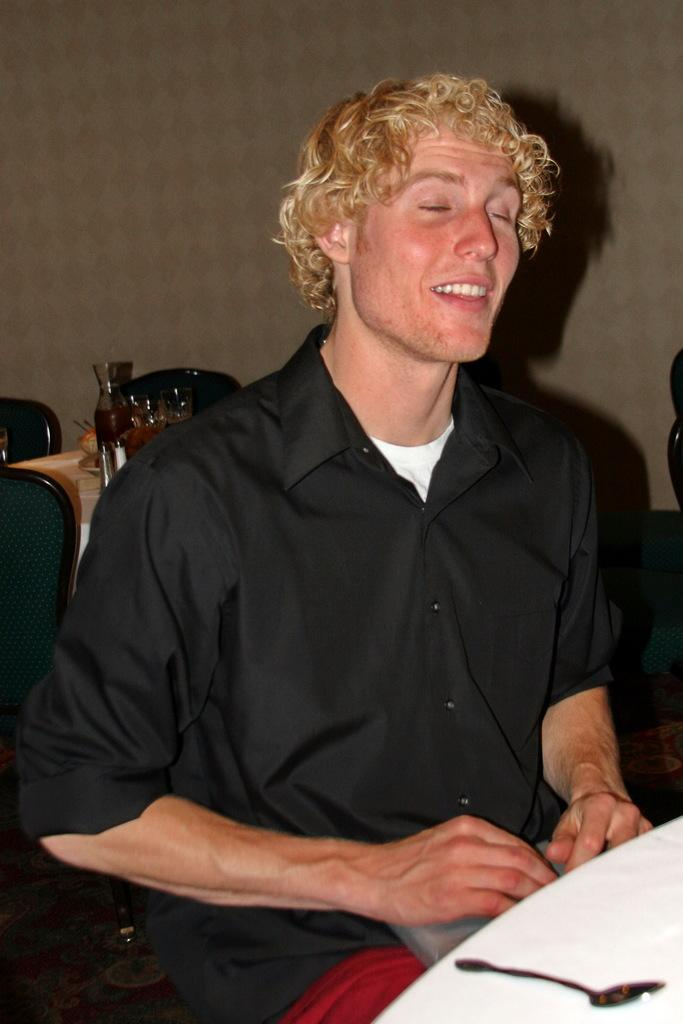Who is present in the image? There is a man in the image. What is the man wearing? The man is wearing a black shirt. What is the man doing in the image? The man has closed his eyes and is smiling. What object can be seen in the image? There is a spoon in the image. What can be seen in the background of the image? There are glasses, other objects, and chairs in the background of the image. What type of jar is visible in the image? There is no jar present in the image. Who are the man's friends in the image? The image does not show any friends of the man; it only features the man himself. 